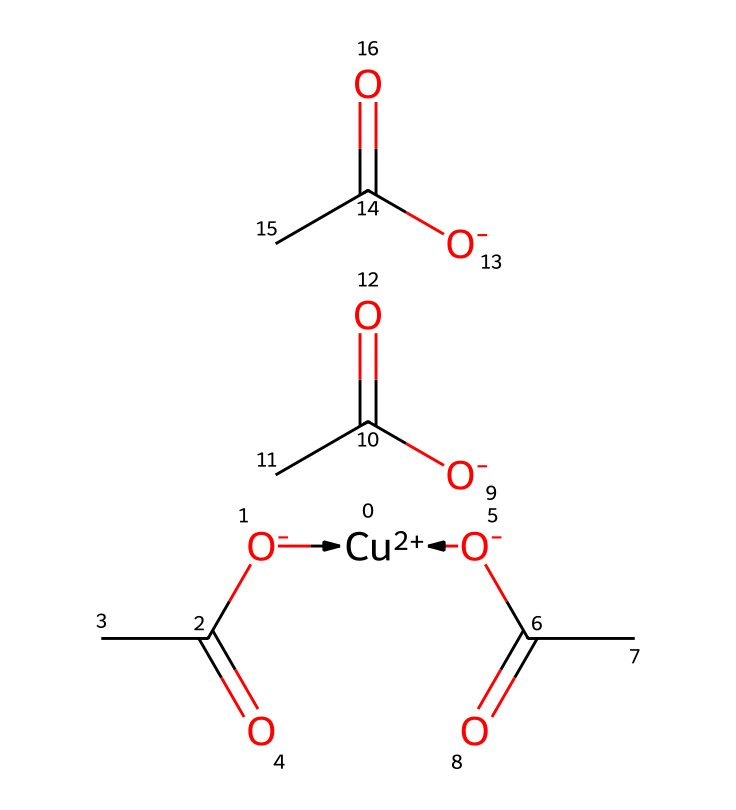How many acetate groups are present in this compound? The chemical structure shows four acetate groups indicated by the repeating structure [O-]C(C)=O, which appears four times in the SMILES notation.
Answer: four What is the oxidation state of copper in this compound? In the compound, the notation [Cu+2] indicates that copper has a +2 oxidation state.
Answer: +2 What type of compound is copper(II) acetate classified as? Copper(II) acetate is classified as a coordination compound due to the presence of a central metal atom (Cu) bonded to surrounding ligands (acetate groups).
Answer: coordination compound How many total atoms are present in the coordination compound? The compound consists of one copper atom, four oxygen atoms from the acetate groups, and four carbon atoms, totaling nine atoms (1 Cu + 4 O + 4 C).
Answer: nine Which ions are included in the structure of copper(II) acetate? The structure includes the copper ion [Cu+2] and acetate ions ([O-]C(C)=O). The acetate ion is responsible for its coordination nature.
Answer: copper ion and acetate ions What role do the acetate groups play in this coordination compound? The acetate groups act as bidentate ligands, meaning each acetate can coordinate to the copper ion at two sites, enhancing stability in the coordination complex.
Answer: bidentate ligands 